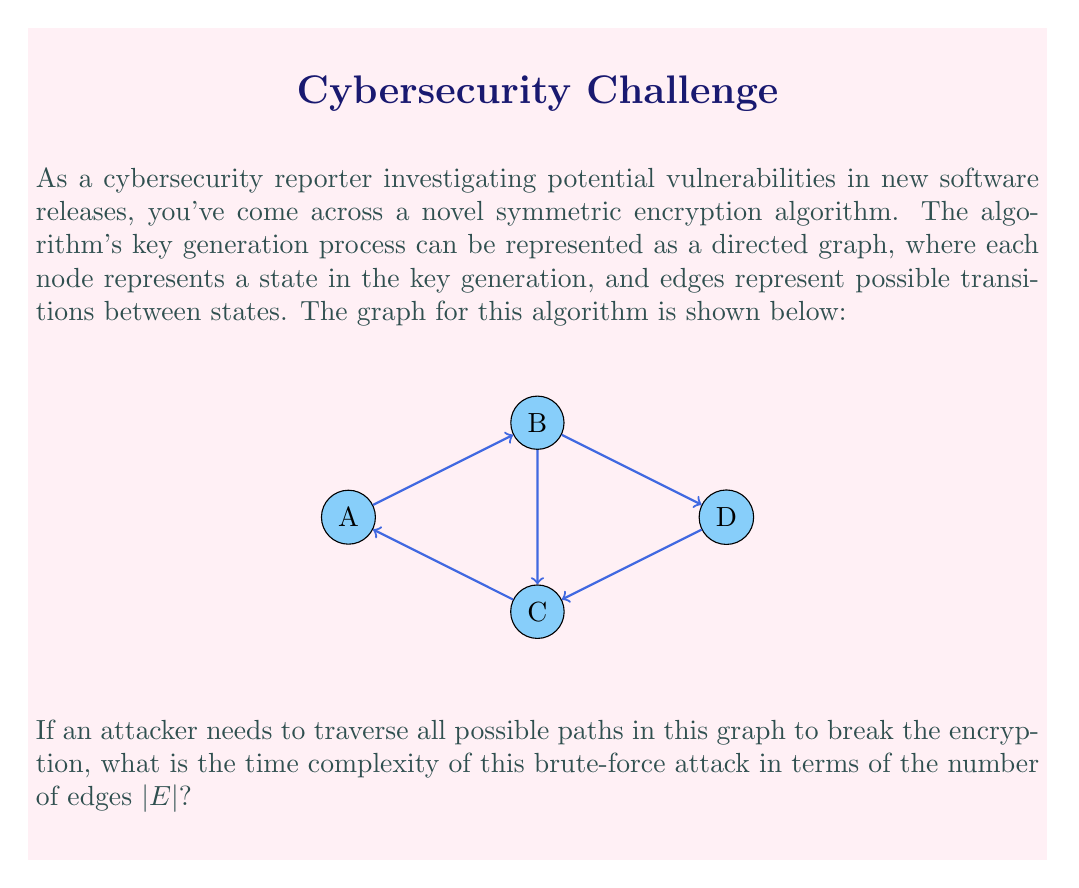Solve this math problem. To analyze the time complexity of traversing all possible paths in this graph, we need to consider the following steps:

1) First, we need to identify the structure of the graph. This is a directed graph with cycles.

2) In a graph with cycles, the number of possible paths can be infinite. However, for a brute-force attack, we're interested in the number of unique paths up to a certain length.

3) The maximum number of unique paths of length $k$ in a directed graph is bounded by $O(|E|^k)$, where $|E|$ is the number of edges in the graph.

4) In cryptanalysis, we often consider attacks that take time exponential in the security parameter. Here, we can consider the number of edges $|E|$ as our security parameter.

5) The time to generate all paths up to length $k$ would be:

   $$T(k) = O(|E| + |E|^2 + |E|^3 + ... + |E|^k) = O(|E|^k)$$

6) For a thorough brute-force attack, $k$ should be at least equal to $|E|$, as this would allow for paths that visit each edge at least once.

7) Therefore, the time complexity of the brute-force attack would be:

   $$O(|E|^{|E|})$$

This represents an upper bound on the time complexity of the attack.
Answer: $O(|E|^{|E|})$ 